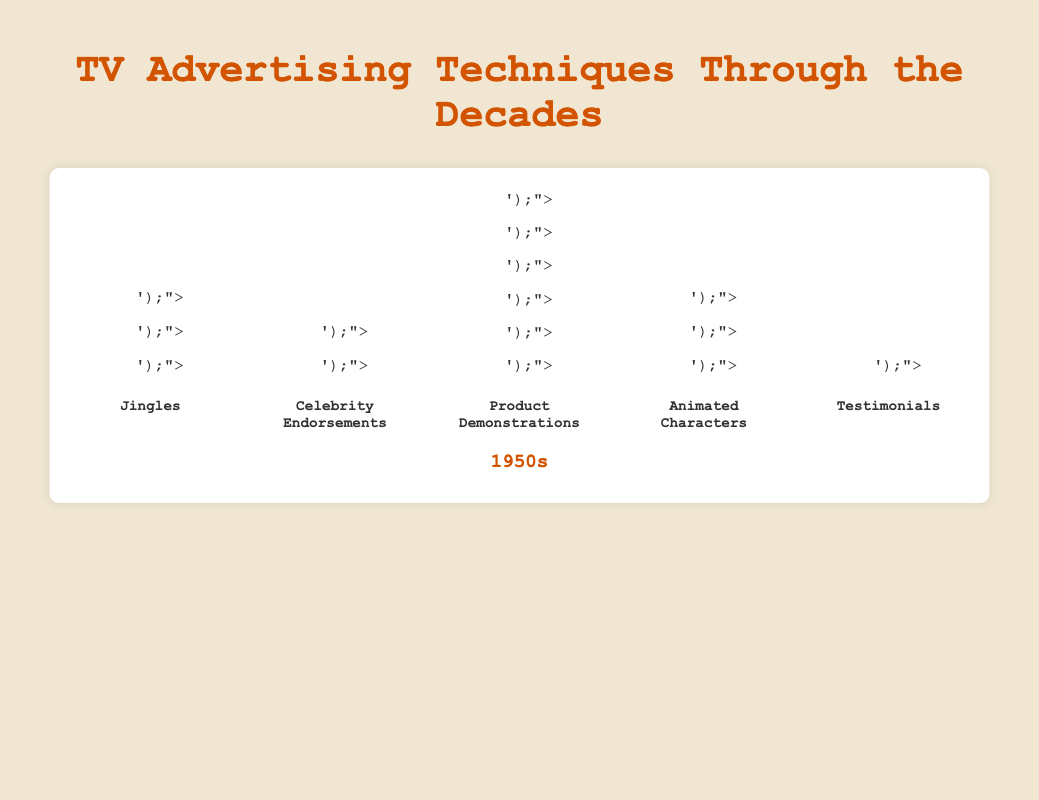How many techniques are represented in each decade? There are five distinct techniques shown for each decade: Jingles, Celebrity Endorsements, Product Demonstrations, Animated Characters, and Testimonials.
Answer: 5 Which decade has the highest number of Celebrity Endorsements? We need to compare the count of Celebrity Endorsements icons across all decades. The highest count is in the 1990s with 9 icons.
Answer: 1990s What is the total number of icons representing Jingles in the entire chart? Sum the number of Jingles icons across all decades: 8 (1950s) + 10 (1960s) + 7 (1970s) + 5 (1980s) + 3 (1990s). This results in 8 + 10 + 7 + 5 + 3 = 33.
Answer: 33 Between the 1970s and the 1980s, which technique saw the largest decrease in usage? Compare the count of each technique's icons between 1970s and 1980s. Jingles decreased from 7 to 5 (decrease of 2), Celebrity Endorsements increased (so not considered), Product Demonstrations decreased from 4 to 3 (decrease of 1), Animated Characters increased (so not considered), Testimonials decreased from 5 to 4 (decrease of 1). Therefore, Jingles saw the largest decrease.
Answer: Jingles Which technique was least used in the 1950s? Count the icons for each technique in the 1950s: Jingles (8), Celebrity Endorsements (2), Product Demonstrations (6), Animated Characters (3), Testimonials (1). Testimonials have the lowest count with 1 icon.
Answer: Testimonials In the 1990s, which two techniques have the same number of icons? Compare the icon counts for all techniques in the 1990s: Jingles (3), Celebrity Endorsements (9), Product Demonstrations (2), Animated Characters (4), Testimonials (6). None have the same number of icons.
Answer: None Did the usage of Animated Characters increase or decrease from the 1950s to the 1990s? Count the icons for Animated Characters in the 1950s (3) and the 1990s (4). There is an increase from 3 to 4.
Answer: Increase What's the sum of icons for Product Demonstrations and Testimonials in the 1980s? Count the icons for Product Demonstrations (3) and Testimonials (4) in the 1980s. The sum is 3 + 4 = 7.
Answer: 7 Which decade has the maximum total number of icons across all techniques? Sum the icons for all techniques in each decade:
- 1950s: 8 (Jingles) + 2 (Celebrity Endorsements) + 6 (Product Demonstrations) + 3 (Animated Characters) + 1 (Testimonials) = 20
- 1960s: 10 (Jingles) + 4 (Celebrity Endorsements) + 5 (Product Demonstrations) + 5 (Animated Characters) + 3 (Testimonials) = 27
- 1970s: 7 (Jingles) + 6 (Celebrity Endorsements) + 4 (Product Demonstrations) + 4 (Animated Characters) + 5 (Testimonials) = 26
- 1980s: 5 (Jingles) + 8 (Celebrity Endorsements) + 3 (Product Demonstrations) + 6 (Animated Characters) + 4 (Testimonials) = 26
- 1990s: 3 (Jingles) + 9 (Celebrity Endorsements) + 2 (Product Demonstrations) + 4 (Animated Characters) + 6 (Testimonials) = 24. 
The 1960s have the highest total with 27 icons.
Answer: 1960s 